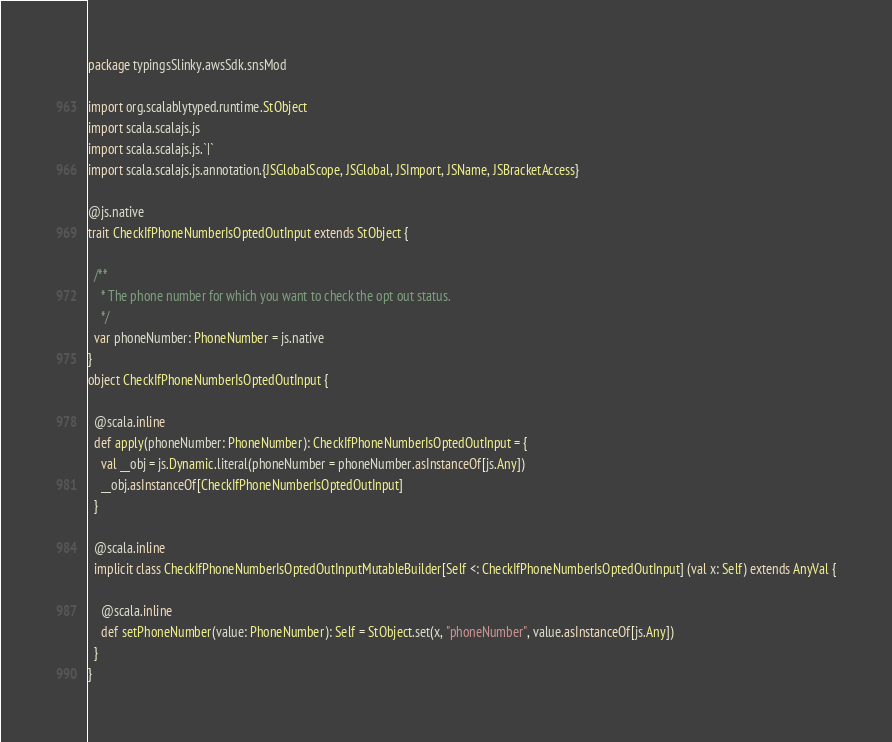<code> <loc_0><loc_0><loc_500><loc_500><_Scala_>package typingsSlinky.awsSdk.snsMod

import org.scalablytyped.runtime.StObject
import scala.scalajs.js
import scala.scalajs.js.`|`
import scala.scalajs.js.annotation.{JSGlobalScope, JSGlobal, JSImport, JSName, JSBracketAccess}

@js.native
trait CheckIfPhoneNumberIsOptedOutInput extends StObject {
  
  /**
    * The phone number for which you want to check the opt out status.
    */
  var phoneNumber: PhoneNumber = js.native
}
object CheckIfPhoneNumberIsOptedOutInput {
  
  @scala.inline
  def apply(phoneNumber: PhoneNumber): CheckIfPhoneNumberIsOptedOutInput = {
    val __obj = js.Dynamic.literal(phoneNumber = phoneNumber.asInstanceOf[js.Any])
    __obj.asInstanceOf[CheckIfPhoneNumberIsOptedOutInput]
  }
  
  @scala.inline
  implicit class CheckIfPhoneNumberIsOptedOutInputMutableBuilder[Self <: CheckIfPhoneNumberIsOptedOutInput] (val x: Self) extends AnyVal {
    
    @scala.inline
    def setPhoneNumber(value: PhoneNumber): Self = StObject.set(x, "phoneNumber", value.asInstanceOf[js.Any])
  }
}
</code> 